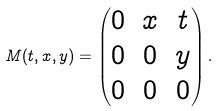<formula> <loc_0><loc_0><loc_500><loc_500>M ( t , x , y ) = \begin{pmatrix} 0 & x & t \\ 0 & 0 & y \\ 0 & 0 & 0 \end{pmatrix} .</formula> 